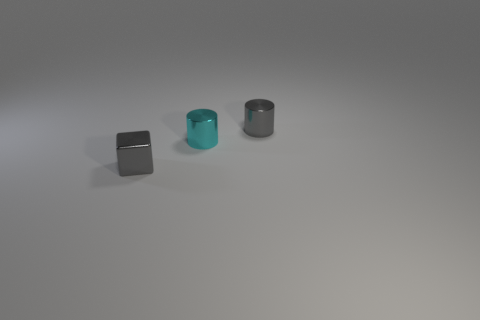Add 2 metal cylinders. How many objects exist? 5 Subtract 1 cylinders. How many cylinders are left? 1 Subtract all cylinders. How many objects are left? 1 Subtract all brown cubes. Subtract all gray cylinders. How many cubes are left? 1 Subtract all green metal cubes. Subtract all tiny gray cubes. How many objects are left? 2 Add 2 shiny cubes. How many shiny cubes are left? 3 Add 1 blocks. How many blocks exist? 2 Subtract 0 yellow blocks. How many objects are left? 3 